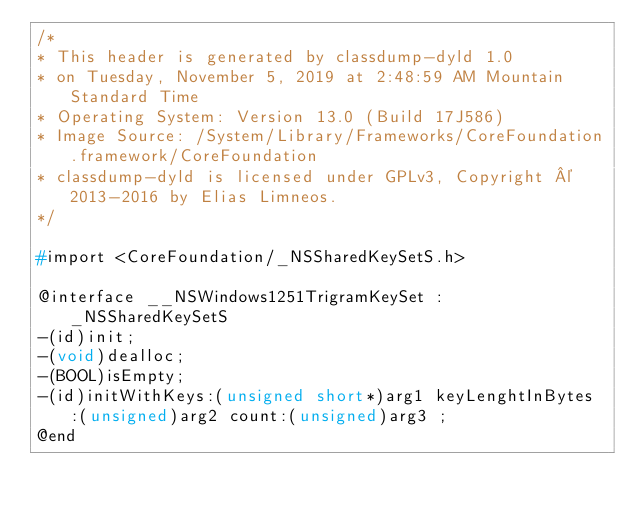<code> <loc_0><loc_0><loc_500><loc_500><_C_>/*
* This header is generated by classdump-dyld 1.0
* on Tuesday, November 5, 2019 at 2:48:59 AM Mountain Standard Time
* Operating System: Version 13.0 (Build 17J586)
* Image Source: /System/Library/Frameworks/CoreFoundation.framework/CoreFoundation
* classdump-dyld is licensed under GPLv3, Copyright © 2013-2016 by Elias Limneos.
*/

#import <CoreFoundation/_NSSharedKeySetS.h>

@interface __NSWindows1251TrigramKeySet : _NSSharedKeySetS
-(id)init;
-(void)dealloc;
-(BOOL)isEmpty;
-(id)initWithKeys:(unsigned short*)arg1 keyLenghtInBytes:(unsigned)arg2 count:(unsigned)arg3 ;
@end

</code> 